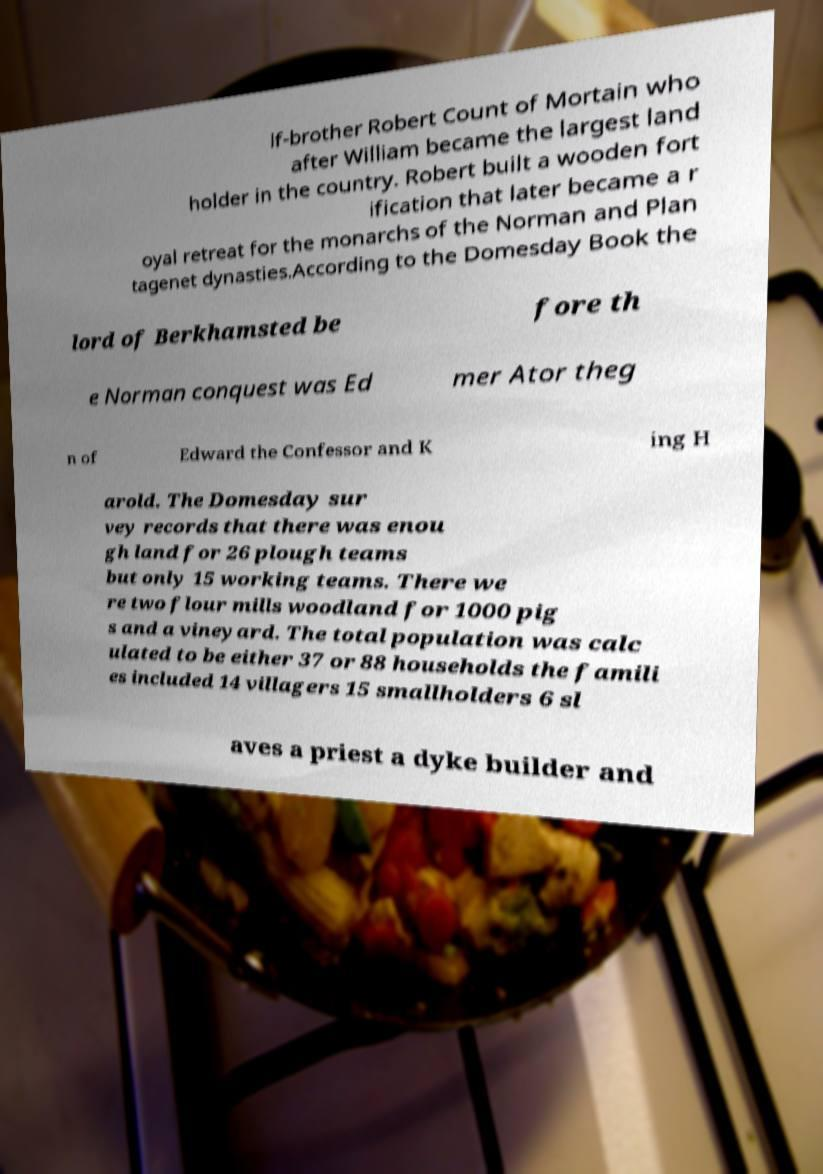There's text embedded in this image that I need extracted. Can you transcribe it verbatim? lf-brother Robert Count of Mortain who after William became the largest land holder in the country. Robert built a wooden fort ification that later became a r oyal retreat for the monarchs of the Norman and Plan tagenet dynasties.According to the Domesday Book the lord of Berkhamsted be fore th e Norman conquest was Ed mer Ator theg n of Edward the Confessor and K ing H arold. The Domesday sur vey records that there was enou gh land for 26 plough teams but only 15 working teams. There we re two flour mills woodland for 1000 pig s and a vineyard. The total population was calc ulated to be either 37 or 88 households the famili es included 14 villagers 15 smallholders 6 sl aves a priest a dyke builder and 